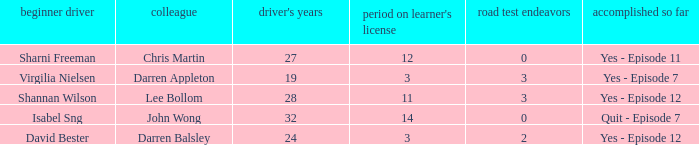What is the average number of years on learners of the drivers over the age of 24 with less than 0 attempts at the licence test? None. 